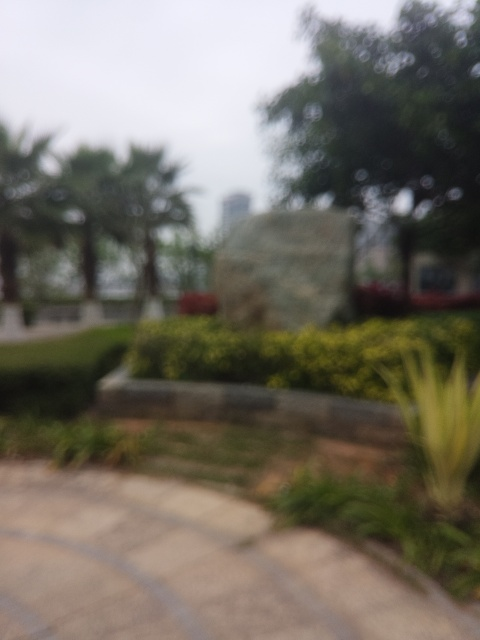Are there any distinguishable features that could tell us more about the location or time of year? Despite the blurriness, it's clear that there's plenty of green foliage, suggesting that the location is likely to be in a season where plants are in bloom, which points to spring or summer. The attire of any visible figures or additional context, such as signage that might peek through the blur, could provide more clues about the location. 